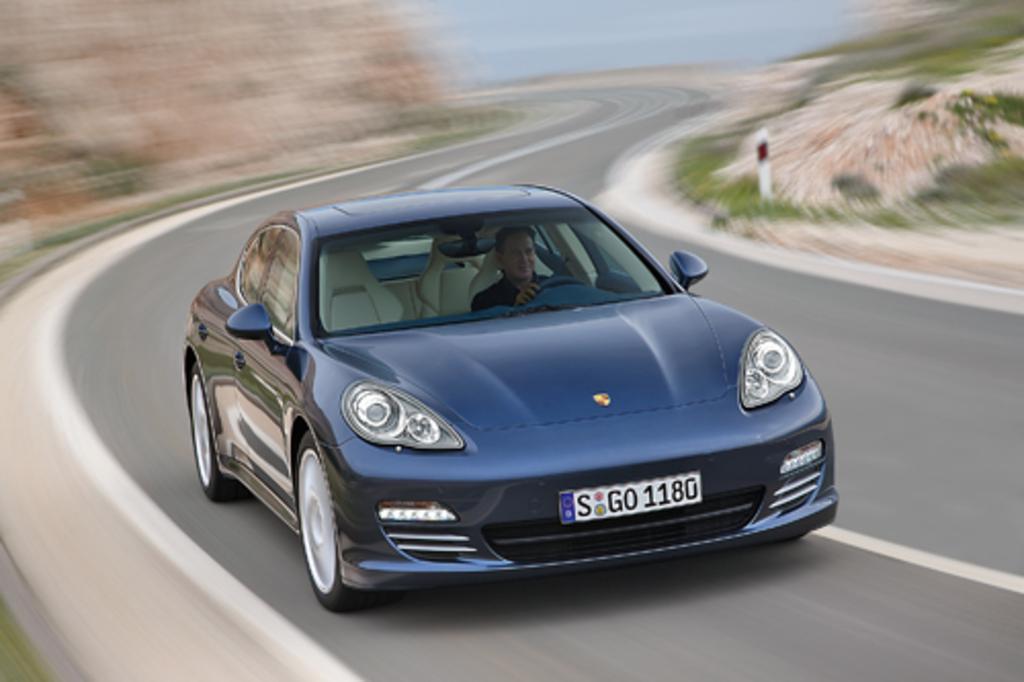How would you summarize this image in a sentence or two? In the image we can see a car, black in color. In the car there is a man sitting, wearing clothes. These are the headlight and number plate of the vehicle. There is a road and white lines on the road, we can even see grass. 